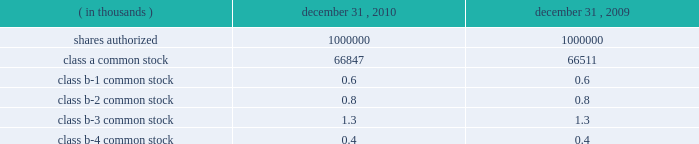Interest rate derivatives .
In connection with the issuance of floating rate debt in august and october 2008 , the company entered into three interest rate swap contracts , designated as cash flow hedges , for purposes of hedging against a change in interest payments due to fluctuations in the underlying benchmark rate .
In december 2010 , the company approved a plan to refinance the term loan in january 2011 resulting in an $ 8.6 million loss on derivative instruments as a result of ineffectiveness on the associated interest rate swap contract .
To mitigate counterparty credit risk , the interest rate swap contracts required collateralization by both counterparties for the swaps 2019 aggregate net fair value during their respective terms .
Collateral was maintained in the form of cash and adjusted on a daily basis .
In february 2010 , the company entered into a forward starting interest rate swap contract , designated as a cash flow hedge , for purposes of hedging against a change in interest payments due to fluctuations in the underlying benchmark rate between the date of the swap and the forecasted issuance of fixed rate debt in march 2010 .
The swap was highly effective .
Foreign currency derivatives .
In connection with its purchase of bm&fbovespa stock in february 2008 , cme group purchased a put option to hedge against changes in the fair value of bm&fbovespa stock resulting from foreign currency rate fluctuations between the u.s .
Dollar and the brazilian real ( brl ) beyond the option 2019s exercise price .
Lehman brothers special financing inc .
( lbsf ) was the sole counterparty to this option contract .
On september 15 , 2008 , lehman brothers holdings inc .
( lehman ) filed for protection under chapter 11 of the united states bankruptcy code .
The bankruptcy filing of lehman was an event of default that gave the company the right to immediately terminate the put option agreement with lbsf .
In march 2010 , the company recognized a $ 6.0 million gain on derivative instruments as a result of a settlement from the lehman bankruptcy proceedings .
21 .
Capital stock shares outstanding .
The table presents information regarding capital stock: .
Cme group has no shares of preferred stock issued and outstanding .
Associated trading rights .
Members of cme , cbot , nymex and comex own or lease trading rights which entitle them to access the trading floors , discounts on trading fees and the right to vote on certain exchange matters as provided for by the rules of the particular exchange and cme group 2019s or the subsidiaries 2019 organizational documents .
Each class of cme group class b common stock is associated with a membership in a specific division for trading at cme .
A cme trading right is a separate asset that is not part of or evidenced by the associated share of class b common stock of cme group .
The class b common stock of cme group is intended only to ensure that the class b shareholders of cme group retain rights with respect to representation on the board of directors and approval rights with respect to the core rights described below .
Trading rights at cbot are evidenced by class b memberships in cbot , at nymex by class a memberships in nymex and at comex by comex division memberships in comex .
Members of the cbot , nymex and comex exchanges do not have any rights to elect members of the board of directors and are not entitled to receive dividends or other distributions on their memberships .
The company is , however , required to have at least 10 cbot directors ( as defined by its bylaws ) until its 2012 annual meeting. .
What is the percentage of class b-3 common stock in relation with the total class b common stocks in 2009? 
Rationale: considering the sum of all class b common stocks , the percentage is calculated dividing the class b-3 ( 1.3 ) by the total amount .
Computations: (1.3 / ((1.3 + 0.4) + (0.6 + 0.8)))
Answer: 0.41935. 